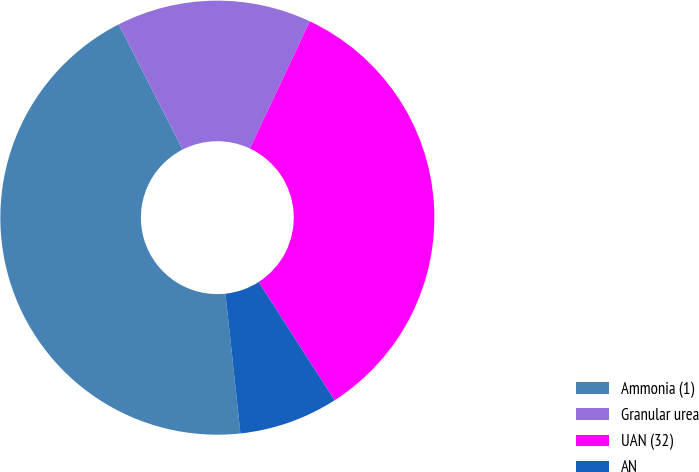Convert chart to OTSL. <chart><loc_0><loc_0><loc_500><loc_500><pie_chart><fcel>Ammonia (1)<fcel>Granular urea<fcel>UAN (32)<fcel>AN<nl><fcel>44.19%<fcel>14.51%<fcel>33.91%<fcel>7.39%<nl></chart> 